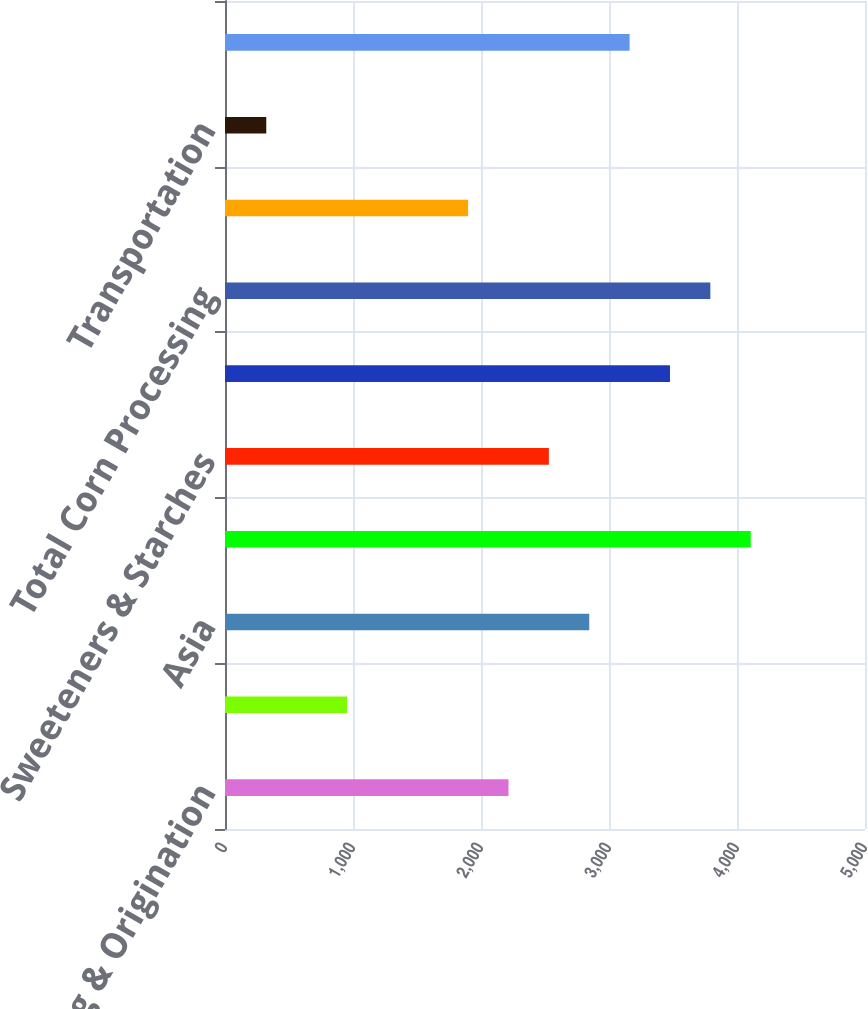Convert chart to OTSL. <chart><loc_0><loc_0><loc_500><loc_500><bar_chart><fcel>Crushing & Origination<fcel>Refining Packaging Biodiesel &<fcel>Asia<fcel>Total Oilseeds Processing<fcel>Sweeteners & Starches<fcel>Bioproducts<fcel>Total Corn Processing<fcel>Merchandising & Handling<fcel>Transportation<fcel>Total Agricultural Services<nl><fcel>2214.8<fcel>953.2<fcel>2845.6<fcel>4107.2<fcel>2530.2<fcel>3476.4<fcel>3791.8<fcel>1899.4<fcel>322.4<fcel>3161<nl></chart> 